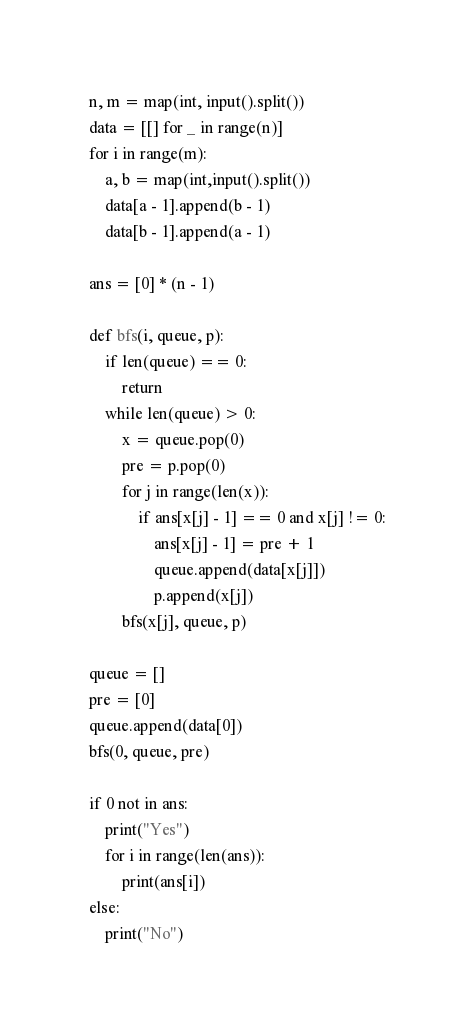Convert code to text. <code><loc_0><loc_0><loc_500><loc_500><_Python_>n, m = map(int, input().split())
data = [[] for _ in range(n)]
for i in range(m):
    a, b = map(int,input().split())
    data[a - 1].append(b - 1)
    data[b - 1].append(a - 1)

ans = [0] * (n - 1)

def bfs(i, queue, p):
    if len(queue) == 0:
        return 
    while len(queue) > 0:
        x = queue.pop(0)
        pre = p.pop(0)
        for j in range(len(x)):
            if ans[x[j] - 1] == 0 and x[j] != 0:
                ans[x[j] - 1] = pre + 1
                queue.append(data[x[j]])
                p.append(x[j])
        bfs(x[j], queue, p)

queue = []
pre = [0]
queue.append(data[0])
bfs(0, queue, pre)

if 0 not in ans:
    print("Yes")
    for i in range(len(ans)):
        print(ans[i])
else:
    print("No")</code> 